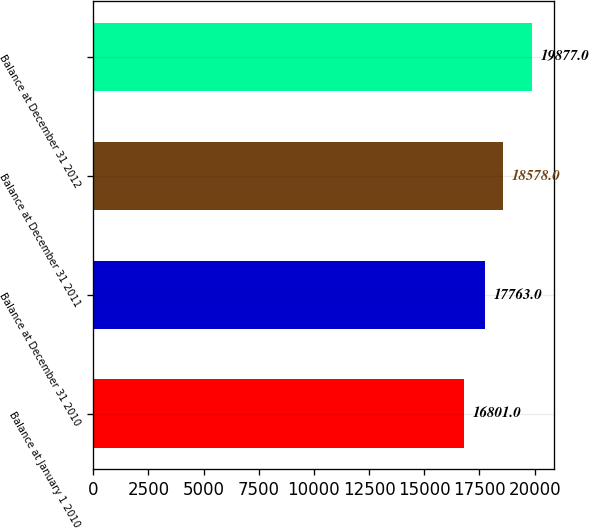Convert chart to OTSL. <chart><loc_0><loc_0><loc_500><loc_500><bar_chart><fcel>Balance at January 1 2010<fcel>Balance at December 31 2010<fcel>Balance at December 31 2011<fcel>Balance at December 31 2012<nl><fcel>16801<fcel>17763<fcel>18578<fcel>19877<nl></chart> 